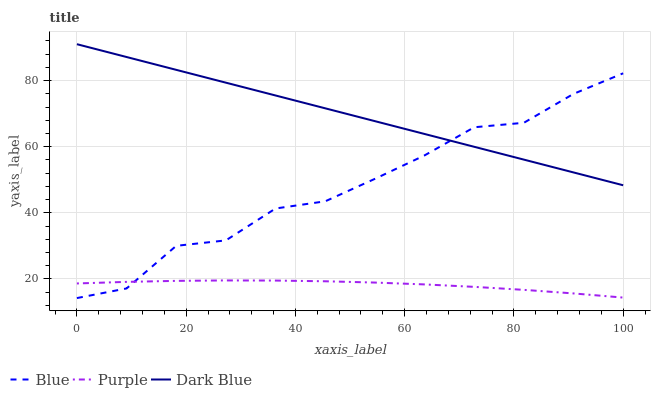Does Purple have the minimum area under the curve?
Answer yes or no. Yes. Does Dark Blue have the maximum area under the curve?
Answer yes or no. Yes. Does Dark Blue have the minimum area under the curve?
Answer yes or no. No. Does Purple have the maximum area under the curve?
Answer yes or no. No. Is Dark Blue the smoothest?
Answer yes or no. Yes. Is Blue the roughest?
Answer yes or no. Yes. Is Purple the smoothest?
Answer yes or no. No. Is Purple the roughest?
Answer yes or no. No. Does Purple have the lowest value?
Answer yes or no. No. Does Dark Blue have the highest value?
Answer yes or no. Yes. Does Purple have the highest value?
Answer yes or no. No. Is Purple less than Dark Blue?
Answer yes or no. Yes. Is Dark Blue greater than Purple?
Answer yes or no. Yes. Does Purple intersect Blue?
Answer yes or no. Yes. Is Purple less than Blue?
Answer yes or no. No. Is Purple greater than Blue?
Answer yes or no. No. Does Purple intersect Dark Blue?
Answer yes or no. No. 